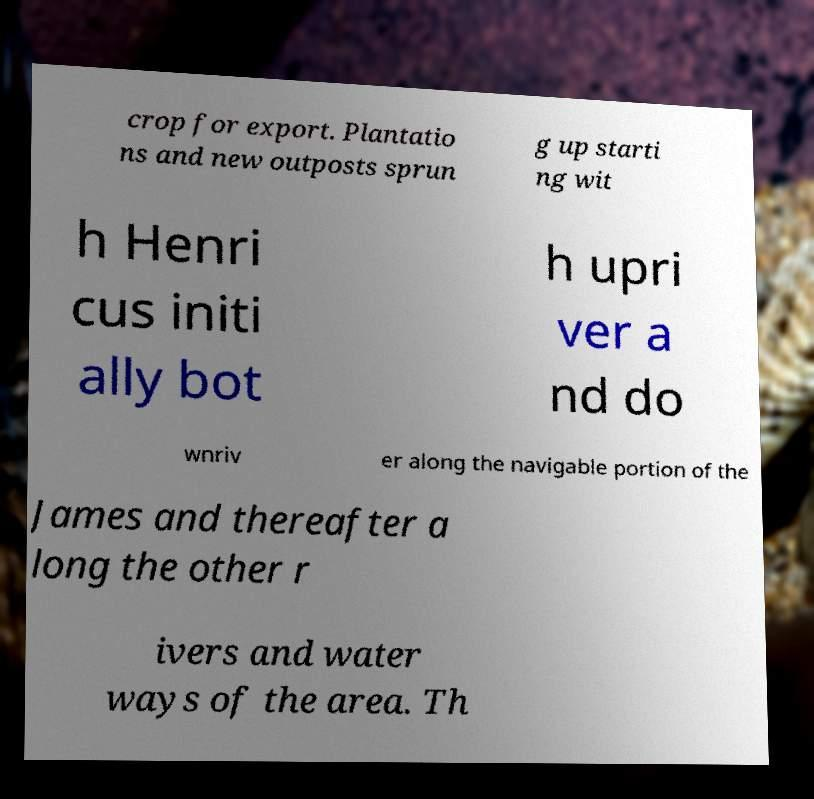I need the written content from this picture converted into text. Can you do that? crop for export. Plantatio ns and new outposts sprun g up starti ng wit h Henri cus initi ally bot h upri ver a nd do wnriv er along the navigable portion of the James and thereafter a long the other r ivers and water ways of the area. Th 